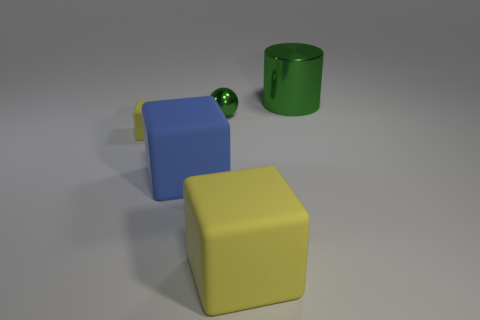Subtract all yellow cubes. How many cubes are left? 1 Add 3 big blue matte things. How many objects exist? 8 Subtract all spheres. How many objects are left? 4 Subtract 0 brown blocks. How many objects are left? 5 Subtract all green metallic objects. Subtract all rubber things. How many objects are left? 0 Add 1 green balls. How many green balls are left? 2 Add 1 big red rubber blocks. How many big red rubber blocks exist? 1 